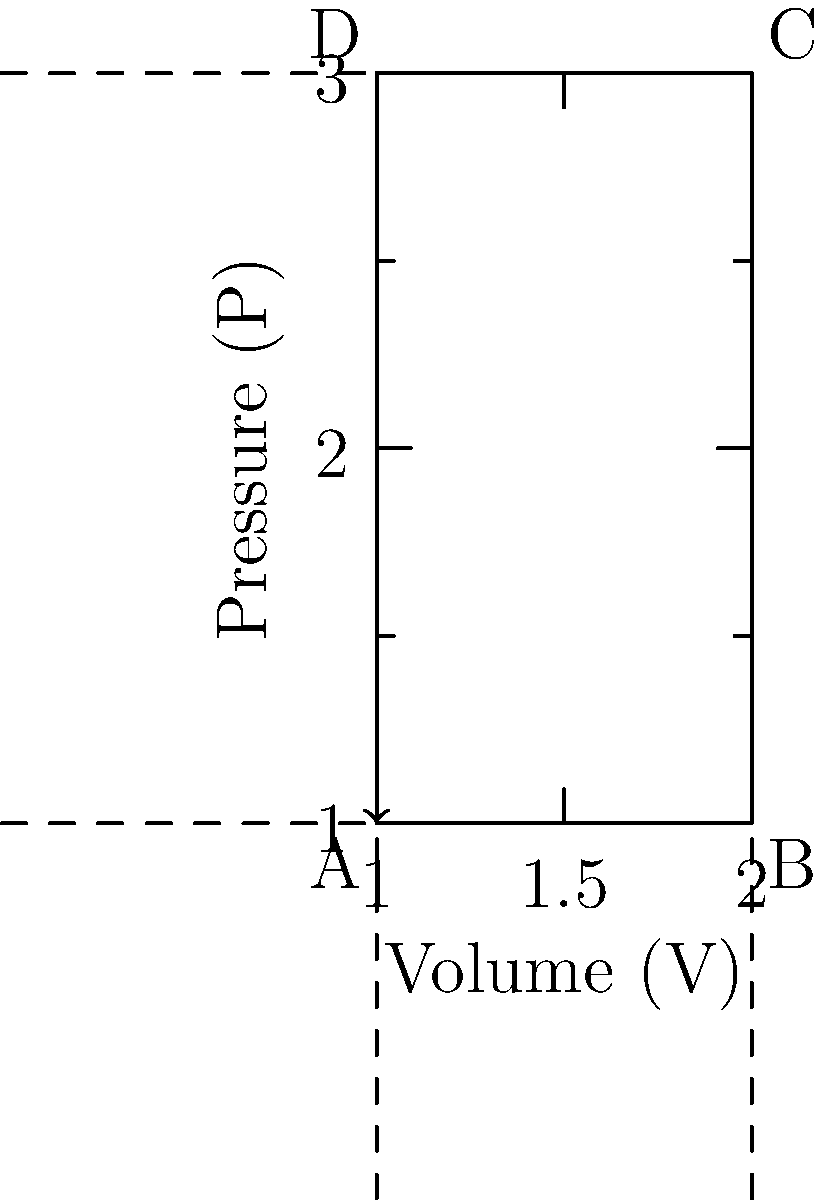During the Industrial Revolution, steam engines played a crucial role in powering machinery. The pressure-volume diagram above represents the cycle of a steam engine. If the area enclosed by the cycle represents the work done by the engine, and the total heat input is 600 J, what is the efficiency of this steam engine? To calculate the efficiency of the steam engine, we need to follow these steps:

1. Calculate the work done by the engine (W):
   The work done is represented by the area of the rectangle ABCD.
   $W = (V_B - V_A) \times (P_C - P_A) = (2 - 1) \times (3 - 1) = 1 \times 2 = 2$ units

2. Convert the work to Joules:
   Since the total heat input is given in Joules, we need to determine the conversion factor.
   Let's assume 1 unit of work = 100 J
   Therefore, $W = 2 \times 100 = 200$ J

3. Calculate the efficiency (η):
   Efficiency is defined as the ratio of work output to heat input.
   $η = \frac{\text{Work output}}{\text{Heat input}} = \frac{W}{Q_{in}}$

   $η = \frac{200 \text{ J}}{600 \text{ J}} = \frac{1}{3} = 0.333$

4. Convert to percentage:
   $η = 0.333 \times 100\% = 33.3\%$

Thus, the efficiency of the steam engine is approximately 33.3%.
Answer: 33.3% 